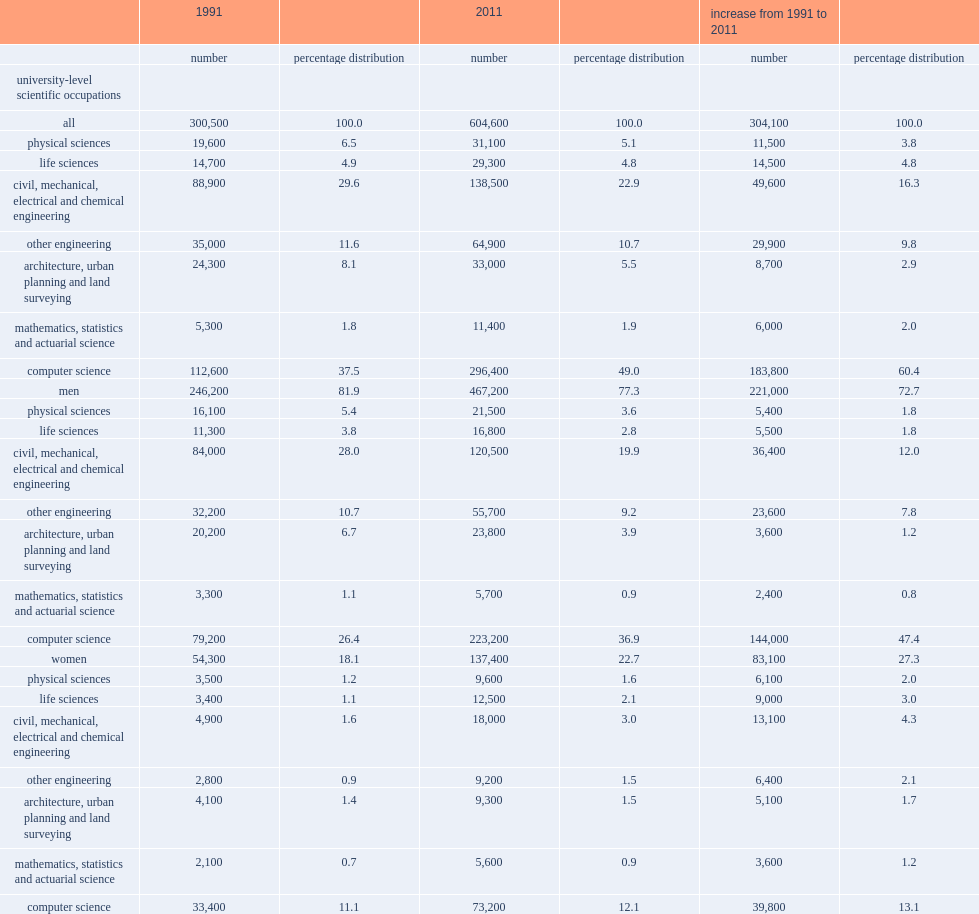Give me the full table as a dictionary. {'header': ['', '1991', '', '2011', '', 'increase from 1991 to 2011', ''], 'rows': [['', 'number', 'percentage distribution', 'number', 'percentage distribution', 'number', 'percentage distribution'], ['university-level scientific occupations', '', '', '', '', '', ''], ['all', '300,500', '100.0', '604,600', '100.0', '304,100', '100.0'], ['physical sciences', '19,600', '6.5', '31,100', '5.1', '11,500', '3.8'], ['life sciences', '14,700', '4.9', '29,300', '4.8', '14,500', '4.8'], ['civil, mechanical, electrical and chemical engineering', '88,900', '29.6', '138,500', '22.9', '49,600', '16.3'], ['other engineering', '35,000', '11.6', '64,900', '10.7', '29,900', '9.8'], ['architecture, urban planning and land surveying', '24,300', '8.1', '33,000', '5.5', '8,700', '2.9'], ['mathematics, statistics and actuarial science', '5,300', '1.8', '11,400', '1.9', '6,000', '2.0'], ['computer science', '112,600', '37.5', '296,400', '49.0', '183,800', '60.4'], ['men', '246,200', '81.9', '467,200', '77.3', '221,000', '72.7'], ['physical sciences', '16,100', '5.4', '21,500', '3.6', '5,400', '1.8'], ['life sciences', '11,300', '3.8', '16,800', '2.8', '5,500', '1.8'], ['civil, mechanical, electrical and chemical engineering', '84,000', '28.0', '120,500', '19.9', '36,400', '12.0'], ['other engineering', '32,200', '10.7', '55,700', '9.2', '23,600', '7.8'], ['architecture, urban planning and land surveying', '20,200', '6.7', '23,800', '3.9', '3,600', '1.2'], ['mathematics, statistics and actuarial science', '3,300', '1.1', '5,700', '0.9', '2,400', '0.8'], ['computer science', '79,200', '26.4', '223,200', '36.9', '144,000', '47.4'], ['women', '54,300', '18.1', '137,400', '22.7', '83,100', '27.3'], ['physical sciences', '3,500', '1.2', '9,600', '1.6', '6,100', '2.0'], ['life sciences', '3,400', '1.1', '12,500', '2.1', '9,000', '3.0'], ['civil, mechanical, electrical and chemical engineering', '4,900', '1.6', '18,000', '3.0', '13,100', '4.3'], ['other engineering', '2,800', '0.9', '9,200', '1.5', '6,400', '2.1'], ['architecture, urban planning and land surveying', '4,100', '1.4', '9,300', '1.5', '5,100', '1.7'], ['mathematics, statistics and actuarial science', '2,100', '0.7', '5,600', '0.9', '3,600', '1.2'], ['computer science', '33,400', '11.1', '73,200', '12.1', '39,800', '13.1']]} By what percentage did computer science contribute to the overall growth of university-level workers? 60.4. Which scientific occupations remained the most common field for women in 2011? Computer science. By what percentage did the civil engineering occupations contribute to the overall increase in the number scientific workers from 1991 to 2011? 16.3. By what percentage did other engineering occupations contribute to the overall increase in the number of scientific workers from 1991 to 2011? 9.8. In which occupation does women's increase from 1991 to 2011 contribute relatively smaller to the total increase in that occupation from 1991 to 2011, computer science or the engineering sectors? Computer science. 